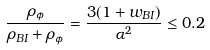Convert formula to latex. <formula><loc_0><loc_0><loc_500><loc_500>\frac { \rho _ { \phi } } { \rho _ { B I } + \rho _ { \phi } } = \frac { 3 ( 1 + w _ { B I } ) } { \alpha ^ { 2 } } \leq 0 . 2</formula> 